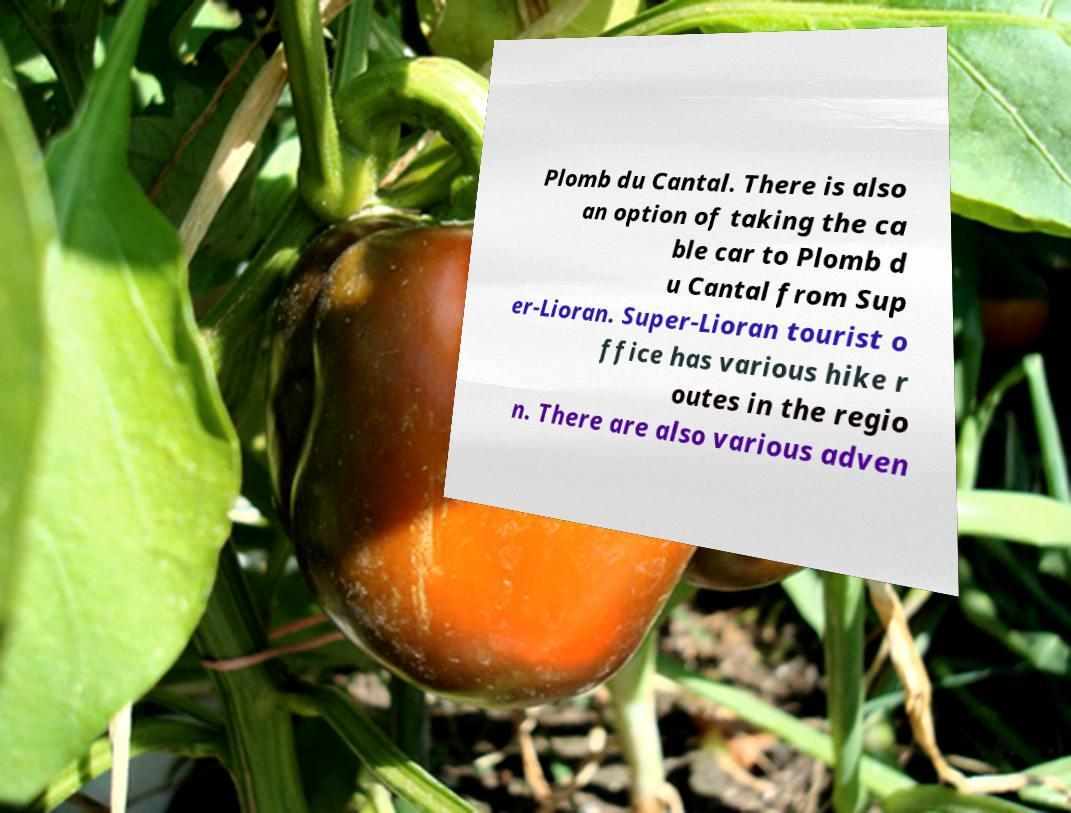Can you read and provide the text displayed in the image?This photo seems to have some interesting text. Can you extract and type it out for me? Plomb du Cantal. There is also an option of taking the ca ble car to Plomb d u Cantal from Sup er-Lioran. Super-Lioran tourist o ffice has various hike r outes in the regio n. There are also various adven 